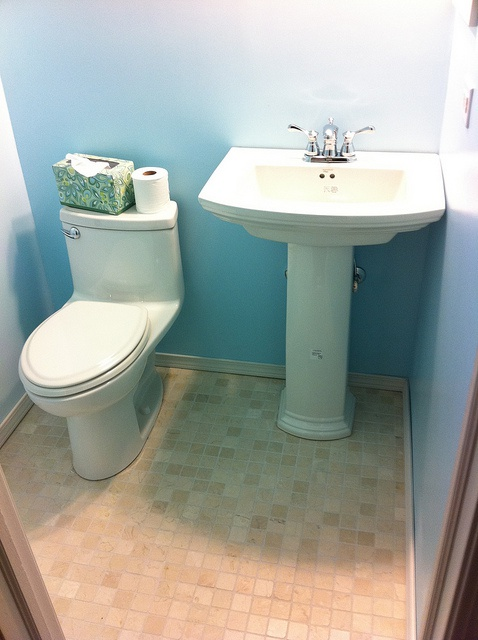Describe the objects in this image and their specific colors. I can see toilet in lightgray, darkgray, ivory, and gray tones and sink in lightgray, ivory, darkgray, and gray tones in this image. 